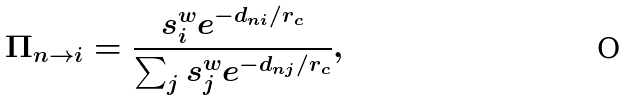<formula> <loc_0><loc_0><loc_500><loc_500>\Pi _ { n \to i } = \frac { s _ { i } ^ { w } e ^ { - d _ { n i } / r _ { c } } } { \sum _ { j } s _ { j } ^ { w } e ^ { - d _ { n j } / r _ { c } } } ,</formula> 